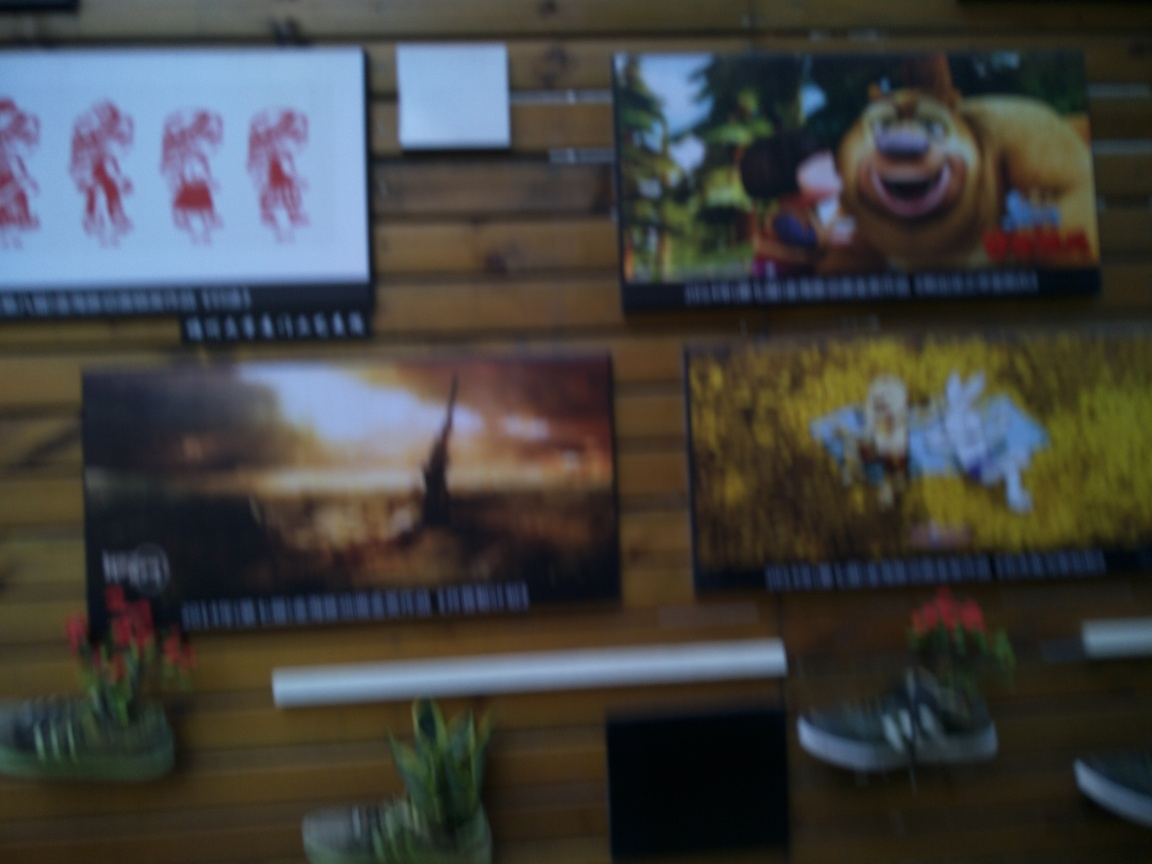What can you infer about the location or setting based on the image? It's challenging to infer much about the location from this blurry image. It appears to be an interior space with a wooden wall upon which a variety of images are hung. Such a setting might suggest a casual environment like a home, a studio, or perhaps a public space like a café that uses wall art to create a welcoming atmosphere. 